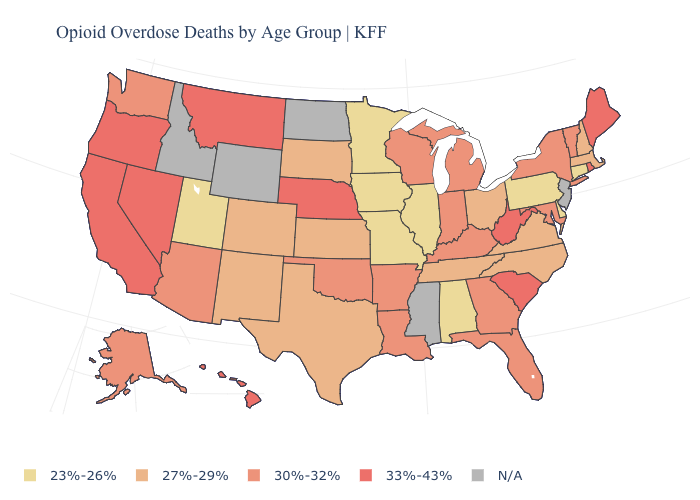Does Delaware have the lowest value in the USA?
Answer briefly. Yes. What is the value of South Dakota?
Write a very short answer. 27%-29%. Among the states that border Massachusetts , which have the lowest value?
Concise answer only. Connecticut. Among the states that border Pennsylvania , which have the lowest value?
Answer briefly. Delaware. What is the value of Nevada?
Give a very brief answer. 33%-43%. Among the states that border Oregon , which have the lowest value?
Concise answer only. Washington. What is the value of California?
Quick response, please. 33%-43%. Which states have the lowest value in the USA?
Be succinct. Alabama, Connecticut, Delaware, Illinois, Iowa, Minnesota, Missouri, Pennsylvania, Utah. Name the states that have a value in the range N/A?
Answer briefly. Idaho, Mississippi, New Jersey, North Dakota, Wyoming. What is the lowest value in states that border Missouri?
Quick response, please. 23%-26%. What is the value of Virginia?
Answer briefly. 27%-29%. How many symbols are there in the legend?
Short answer required. 5. What is the value of Delaware?
Quick response, please. 23%-26%. What is the highest value in the MidWest ?
Give a very brief answer. 33%-43%. 